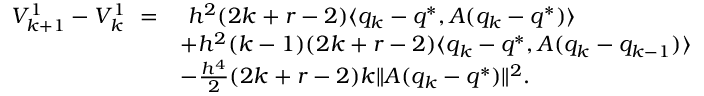Convert formula to latex. <formula><loc_0><loc_0><loc_500><loc_500>\begin{array} { r l } { V _ { k + 1 } ^ { 1 } - V _ { k } ^ { 1 } \ = } & { \ h ^ { 2 } ( 2 k + r - 2 ) \langle q _ { k } - q ^ { * } , A ( q _ { k } - q ^ { * } ) \rangle } \\ & { + h ^ { 2 } ( k - 1 ) ( 2 k + r - 2 ) \langle q _ { k } - q ^ { * } , A ( q _ { k } - q _ { k - 1 } ) \rangle } \\ & { - \frac { h ^ { 4 } } { 2 } ( 2 k + r - 2 ) k \| A ( q _ { k } - q ^ { * } ) \| ^ { 2 } . } \end{array}</formula> 